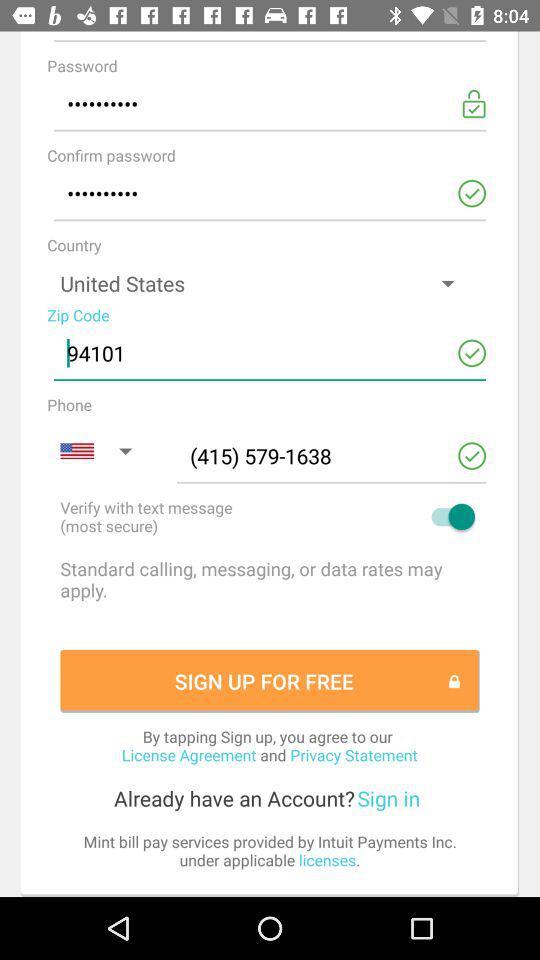To which region does the zip code belong?
When the provided information is insufficient, respond with <no answer>. <no answer> 